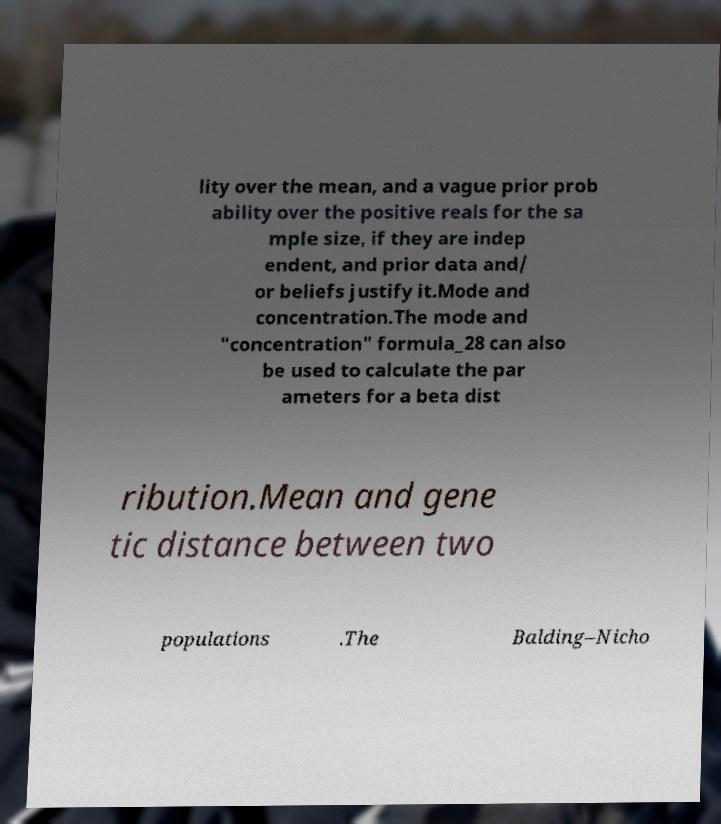Can you accurately transcribe the text from the provided image for me? lity over the mean, and a vague prior prob ability over the positive reals for the sa mple size, if they are indep endent, and prior data and/ or beliefs justify it.Mode and concentration.The mode and "concentration" formula_28 can also be used to calculate the par ameters for a beta dist ribution.Mean and gene tic distance between two populations .The Balding–Nicho 